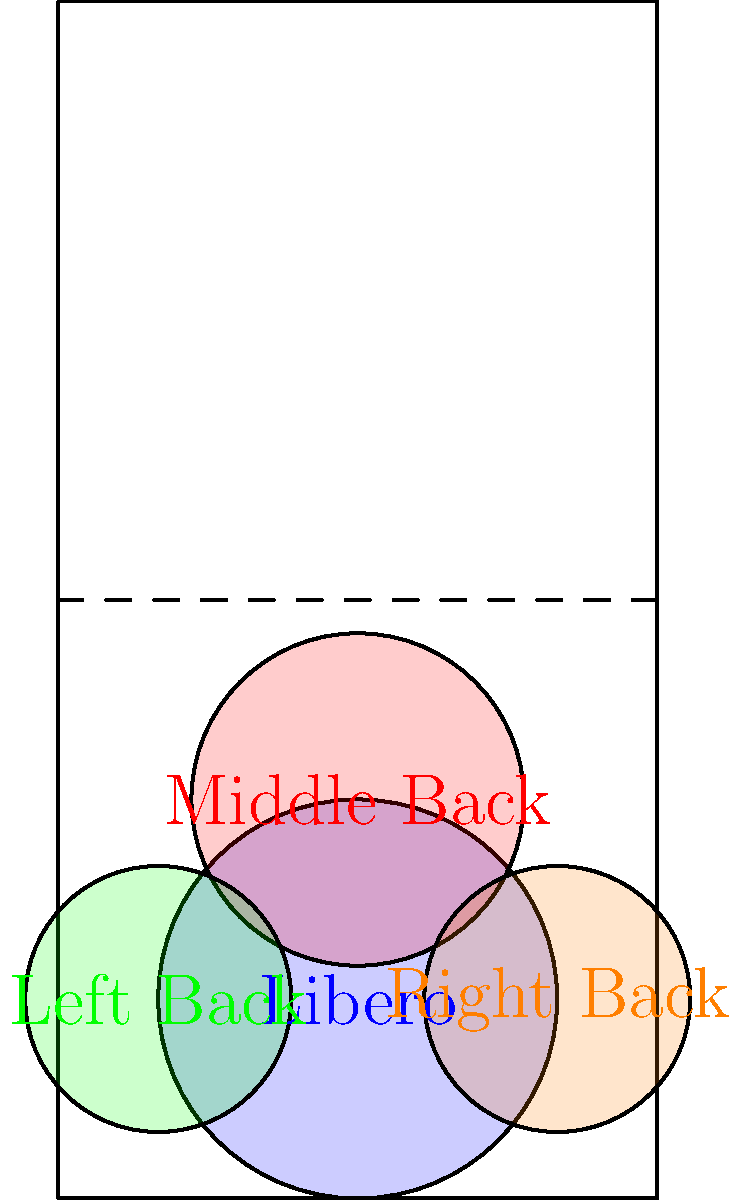In the volleyball court diagram, four defensive positions are shown with their respective coverage areas. The Libero's coverage area has a radius of 3 meters, the Middle Back's area has a radius of 2.5 meters, and both the Left Back and Right Back areas have radii of 2 meters. Calculate the total area covered by all four defensive positions, rounded to the nearest square meter. (Use $\pi \approx 3.14$) To solve this problem, we'll calculate the area of each defensive position's coverage and then sum them up:

1. Libero's area: 
   $A_L = \pi r^2 = 3.14 \times 3^2 = 28.26$ sq meters

2. Middle Back's area:
   $A_M = \pi r^2 = 3.14 \times 2.5^2 = 19.63$ sq meters

3. Left Back's area:
   $A_{LB} = \pi r^2 = 3.14 \times 2^2 = 12.56$ sq meters

4. Right Back's area:
   $A_{RB} = \pi r^2 = 3.14 \times 2^2 = 12.56$ sq meters

Total area:
$A_{total} = A_L + A_M + A_{LB} + A_{RB}$
$A_{total} = 28.26 + 19.63 + 12.56 + 12.56 = 73.01$ sq meters

Rounding to the nearest square meter:
$A_{total} \approx 73$ sq meters
Answer: 73 sq meters 